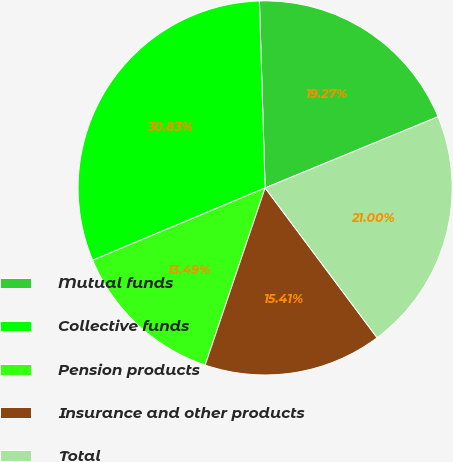Convert chart. <chart><loc_0><loc_0><loc_500><loc_500><pie_chart><fcel>Mutual funds<fcel>Collective funds<fcel>Pension products<fcel>Insurance and other products<fcel>Total<nl><fcel>19.27%<fcel>30.83%<fcel>13.49%<fcel>15.41%<fcel>21.0%<nl></chart> 